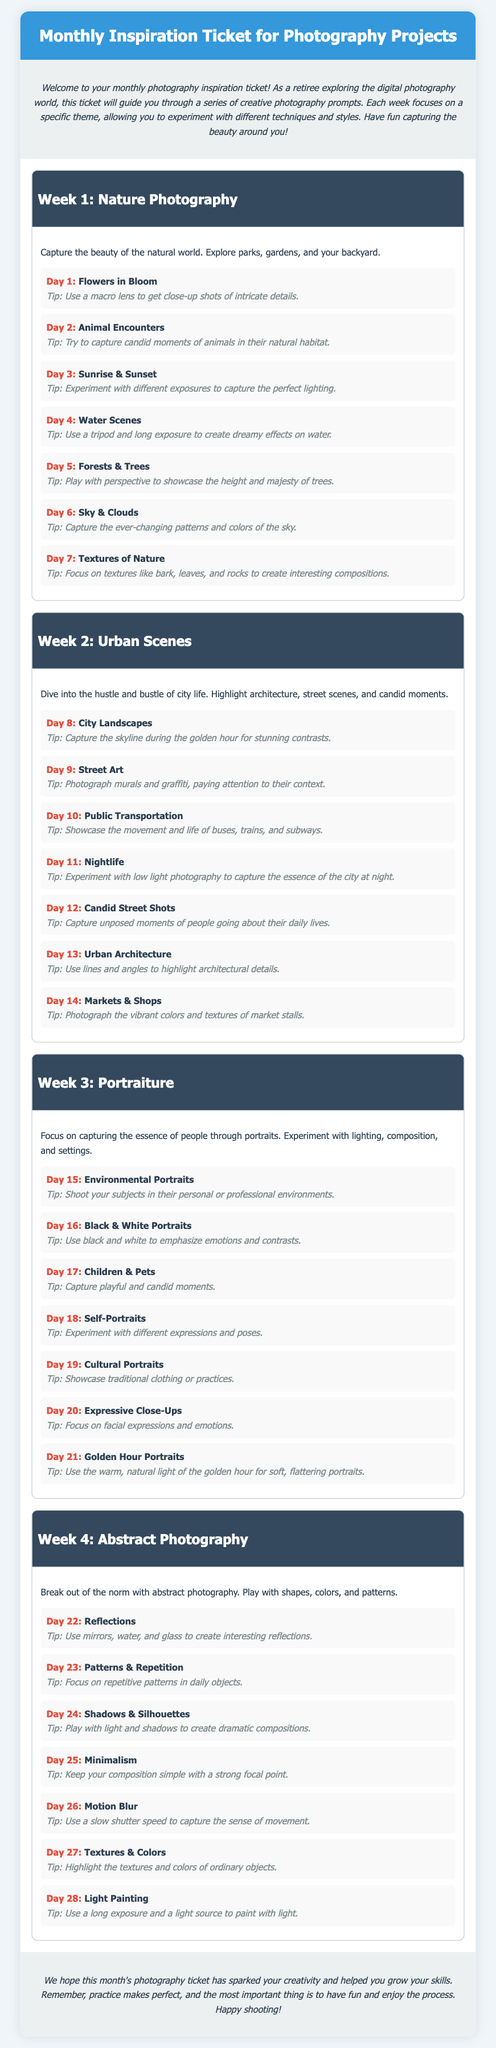What is the title of the document? The title is located in the header section of the document.
Answer: Monthly Inspiration Ticket for Photography Projects How many weeks of prompts are included? The document outlines four distinct weeks, each with its own theme and prompts.
Answer: 4 What is the theme for Week 2? The theme for each week is specified in the week headers throughout the document.
Answer: Urban Scenes What is a suggested technique for Day 3 of Week 1? Each prompt includes a specific tip related to the photography topic for that day.
Answer: Experiment with different exposures to capture the perfect lighting What type of photography is focused on Day 22? Each day's topic gives specific genres of photography to explore.
Answer: Reflections What is the focus of Week 4? The main discussion in the week header indicates the photographic theme for that week.
Answer: Abstract Photography What effect can be achieved using a long exposure? The tips provided show how different techniques can enhance specific photography styles or themes.
Answer: Create dreamy effects on water What should you emphasize in Black & White Portraits? The tips suggest how to enhance the composition and impact of each photograph.
Answer: Emphasize emotions and contrasts What is the general goal of the Monthly Inspiration Ticket? The introduction of the document outlines the purpose of the prompts provided.
Answer: Spark creativity 